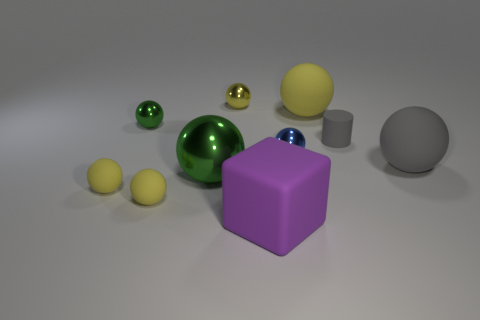Can you describe the colors and materials of the objects in the scene? Certainly! In the scene, we have a variety of spherical objects with different colors and finishes. There's a large green metallic ball, a sizable matte yellow ball, and smaller balls in shiny gold, reflective silver, and matte yellow. Additionally, there's a large matte purple cube and a gray matte cylinder. 